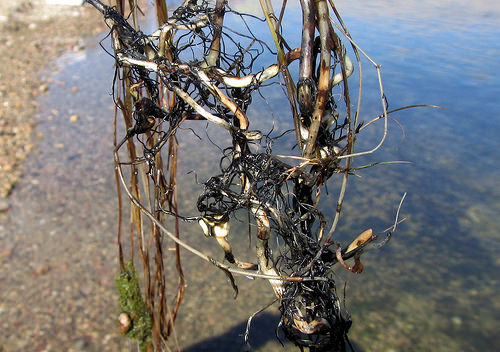<image>
Can you confirm if the tree is behind the water? No. The tree is not behind the water. From this viewpoint, the tree appears to be positioned elsewhere in the scene. 